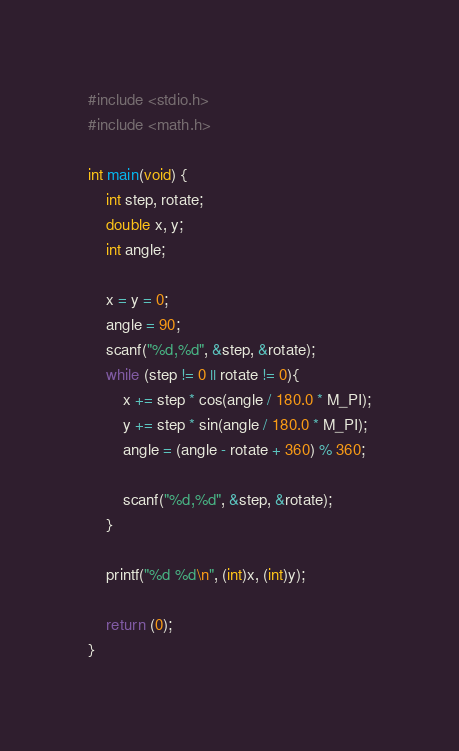<code> <loc_0><loc_0><loc_500><loc_500><_C_>#include <stdio.h>
#include <math.h>

int main(void) {
	int step, rotate;
	double x, y;
	int angle;

	x = y = 0;
	angle = 90;
	scanf("%d,%d", &step, &rotate);
	while (step != 0 || rotate != 0){
		x += step * cos(angle / 180.0 * M_PI);
		y += step * sin(angle / 180.0 * M_PI);
		angle = (angle - rotate + 360) % 360;

		scanf("%d,%d", &step, &rotate);
	}

	printf("%d %d\n", (int)x, (int)y);

	return (0);
}</code> 